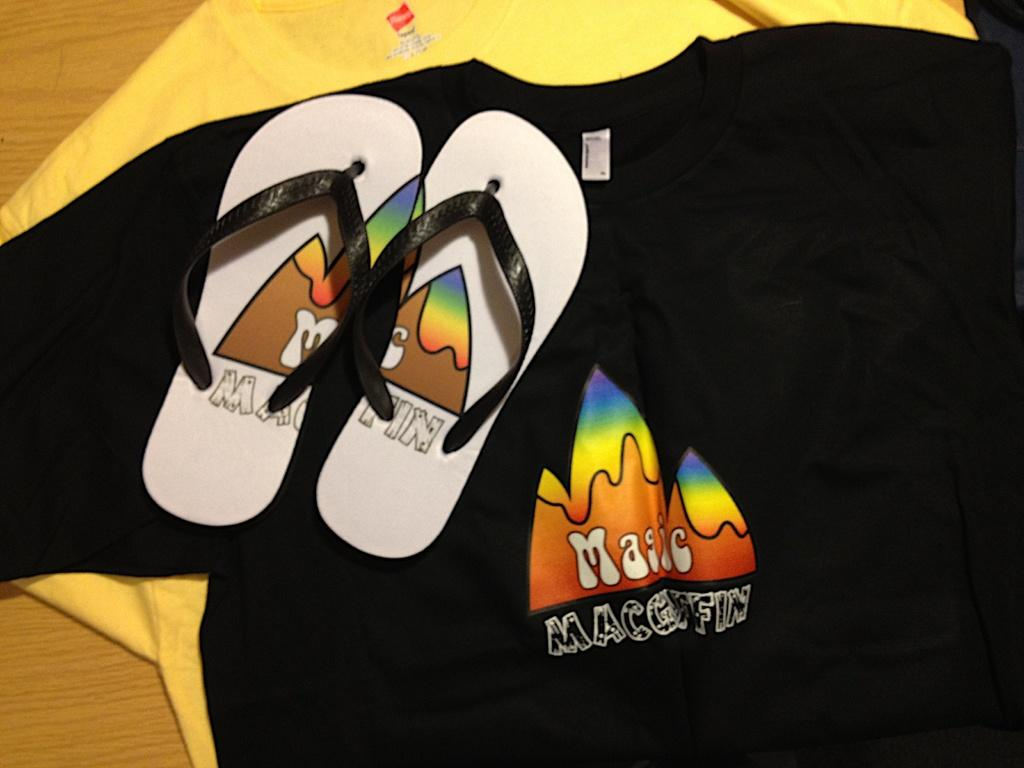What type of clothing is visible in the image? There are t-shirts in the image. Where are the t-shirts located? The t-shirts are on a wooden surface. What division is being taught in the image? There is no division or teaching activity present in the image; it only features t-shirts on a wooden surface. 